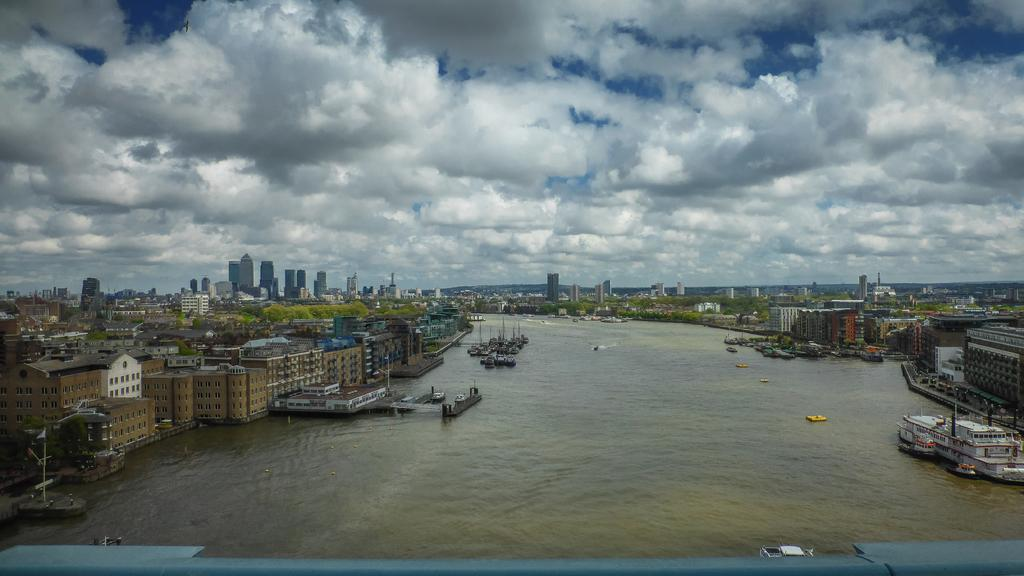What is in the water in the image? There are boats in the water in the image. What can be seen in the background of the image? There are buildings and trees in the background of the image. What colors are the buildings in the image? The buildings have brown, cream, and white colors. What colors are the trees in the image? The trees have green colors. What colors are visible in the sky in the image? The sky has blue and white colors. Where is the scarf being used in the image? There is no scarf present in the image. Can you tell me how many worms are crawling on the boats in the image? There are no worms present in the image; it features boats in the water. 